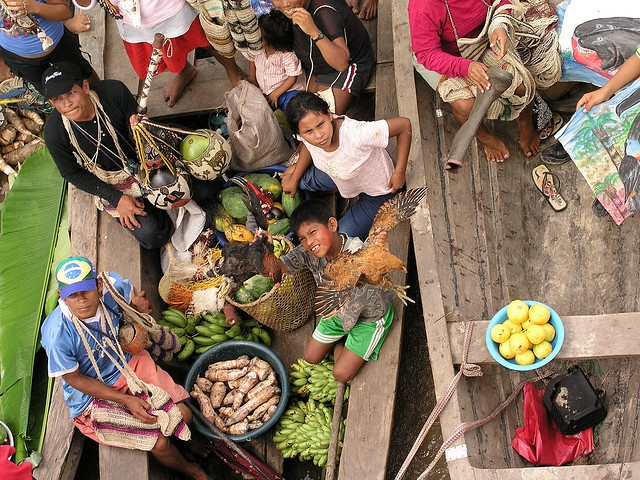Describe the objects in this image and their specific colors. I can see boat in tan, black, and gray tones, boat in tan and gray tones, boat in tan, olive, and black tones, people in tan, brown, and ivory tones, and people in tan, black, brown, and maroon tones in this image. 